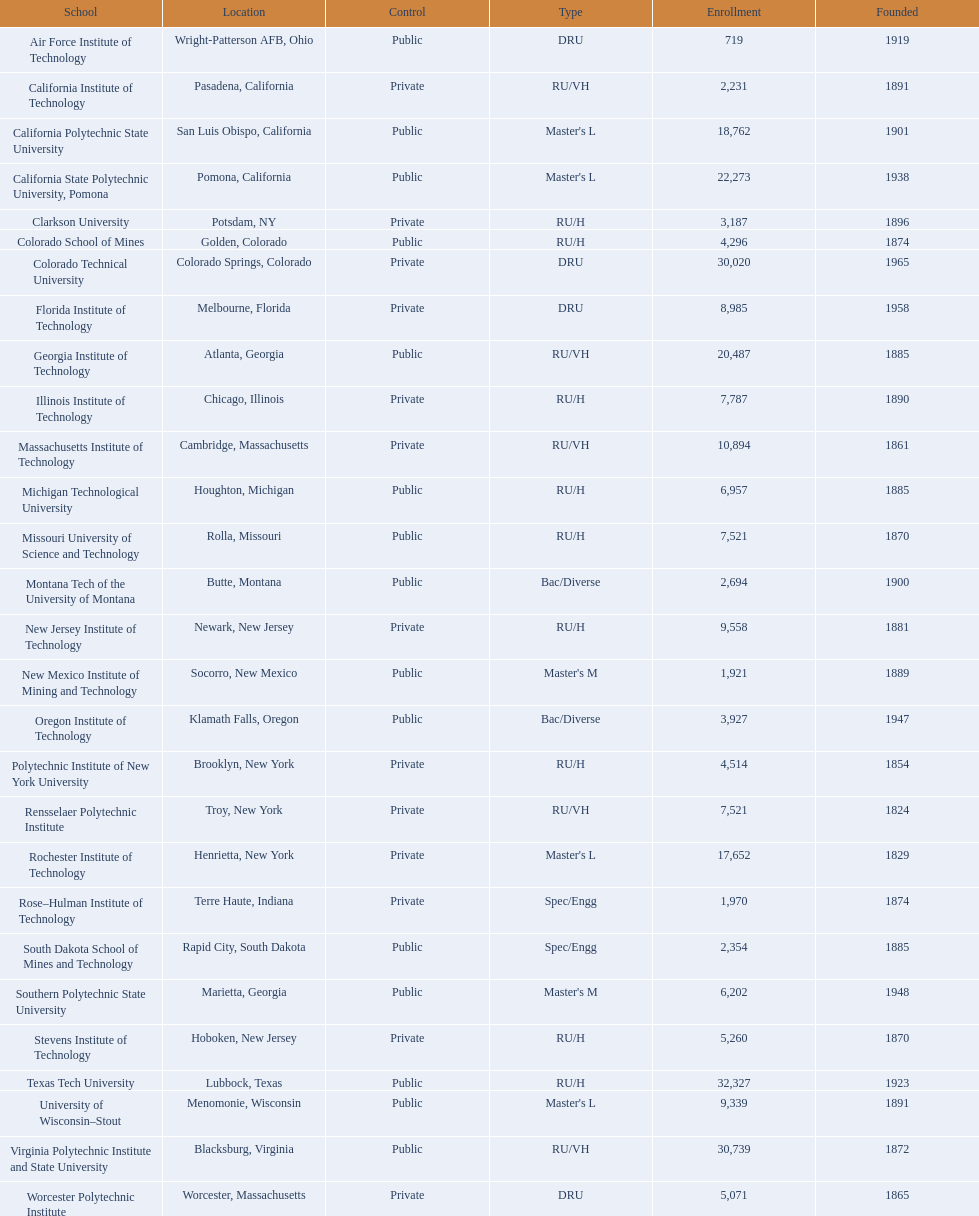What are the noted admission statistics for us universities? 719, 2,231, 18,762, 22,273, 3,187, 4,296, 30,020, 8,985, 20,487, 7,787, 10,894, 6,957, 7,521, 2,694, 9,558, 1,921, 3,927, 4,514, 7,521, 17,652, 1,970, 2,354, 6,202, 5,260, 32,327, 9,339, 30,739, 5,071. From these, which has the maximum amount? 32,327. What are the identified names of us universities? Air Force Institute of Technology, California Institute of Technology, California Polytechnic State University, California State Polytechnic University, Pomona, Clarkson University, Colorado School of Mines, Colorado Technical University, Florida Institute of Technology, Georgia Institute of Technology, Illinois Institute of Technology, Massachusetts Institute of Technology, Michigan Technological University, Missouri University of Science and Technology, Montana Tech of the University of Montana, New Jersey Institute of Technology, New Mexico Institute of Mining and Technology, Oregon Institute of Technology, Polytechnic Institute of New York University, Rensselaer Polytechnic Institute, Rochester Institute of Technology, Rose–Hulman Institute of Technology, South Dakota School of Mines and Technology, Southern Polytechnic State University, Stevens Institute of Technology, Texas Tech University, University of Wisconsin–Stout, Virginia Polytechnic Institute and State University, Worcester Polytechnic Institute. Which of these relate to the previously stated highest enrollment number? Texas Tech University. 